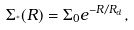Convert formula to latex. <formula><loc_0><loc_0><loc_500><loc_500>\Sigma _ { ^ { * } } ( R ) = \Sigma _ { 0 } e ^ { - R / R _ { d } } ,</formula> 